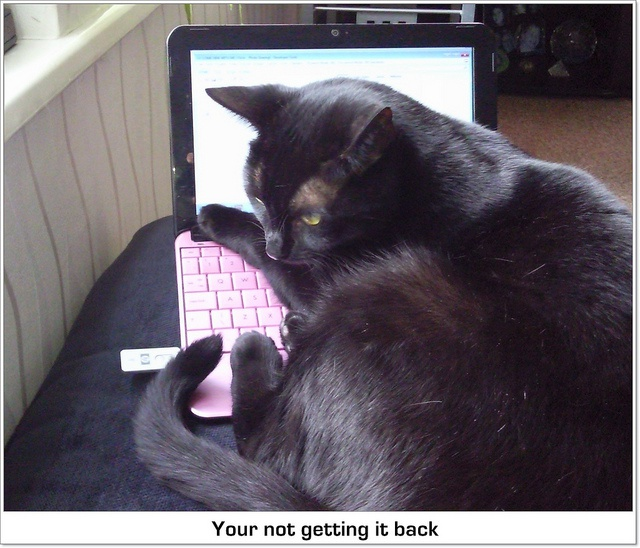Describe the objects in this image and their specific colors. I can see cat in darkgray, black, gray, and purple tones and laptop in darkgray, white, black, and gray tones in this image. 